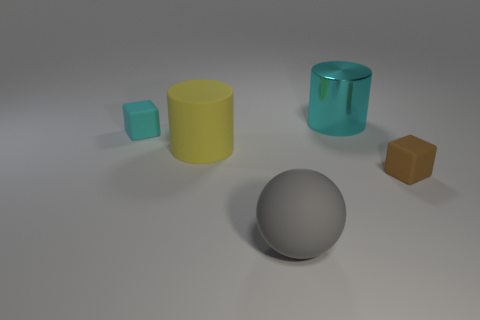Are there the same number of cyan metallic cylinders that are to the left of the gray ball and big gray spheres that are behind the cyan metal cylinder?
Ensure brevity in your answer.  Yes. Is there a cyan shiny object of the same size as the gray matte sphere?
Ensure brevity in your answer.  Yes. What is the size of the yellow rubber cylinder?
Make the answer very short. Large. Are there an equal number of tiny cubes that are on the right side of the cyan metallic cylinder and small cyan matte blocks?
Give a very brief answer. Yes. How many other things are the same color as the big shiny object?
Your response must be concise. 1. There is a rubber object that is both in front of the big yellow thing and left of the big metal thing; what color is it?
Offer a very short reply. Gray. There is a rubber cube to the right of the object behind the tiny rubber cube that is behind the small brown object; what size is it?
Your answer should be compact. Small. How many things are rubber blocks to the right of the large yellow matte cylinder or rubber things that are to the right of the big yellow rubber cylinder?
Your response must be concise. 2. What is the shape of the cyan rubber object?
Make the answer very short. Cube. How many other objects are the same material as the ball?
Your answer should be compact. 3. 